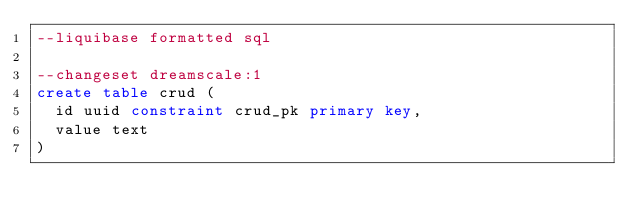<code> <loc_0><loc_0><loc_500><loc_500><_SQL_>--liquibase formatted sql

--changeset dreamscale:1
create table crud (
  id uuid constraint crud_pk primary key,
  value text
)
</code> 